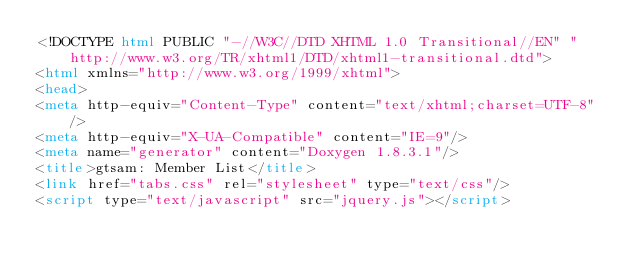<code> <loc_0><loc_0><loc_500><loc_500><_HTML_><!DOCTYPE html PUBLIC "-//W3C//DTD XHTML 1.0 Transitional//EN" "http://www.w3.org/TR/xhtml1/DTD/xhtml1-transitional.dtd">
<html xmlns="http://www.w3.org/1999/xhtml">
<head>
<meta http-equiv="Content-Type" content="text/xhtml;charset=UTF-8"/>
<meta http-equiv="X-UA-Compatible" content="IE=9"/>
<meta name="generator" content="Doxygen 1.8.3.1"/>
<title>gtsam: Member List</title>
<link href="tabs.css" rel="stylesheet" type="text/css"/>
<script type="text/javascript" src="jquery.js"></script></code> 